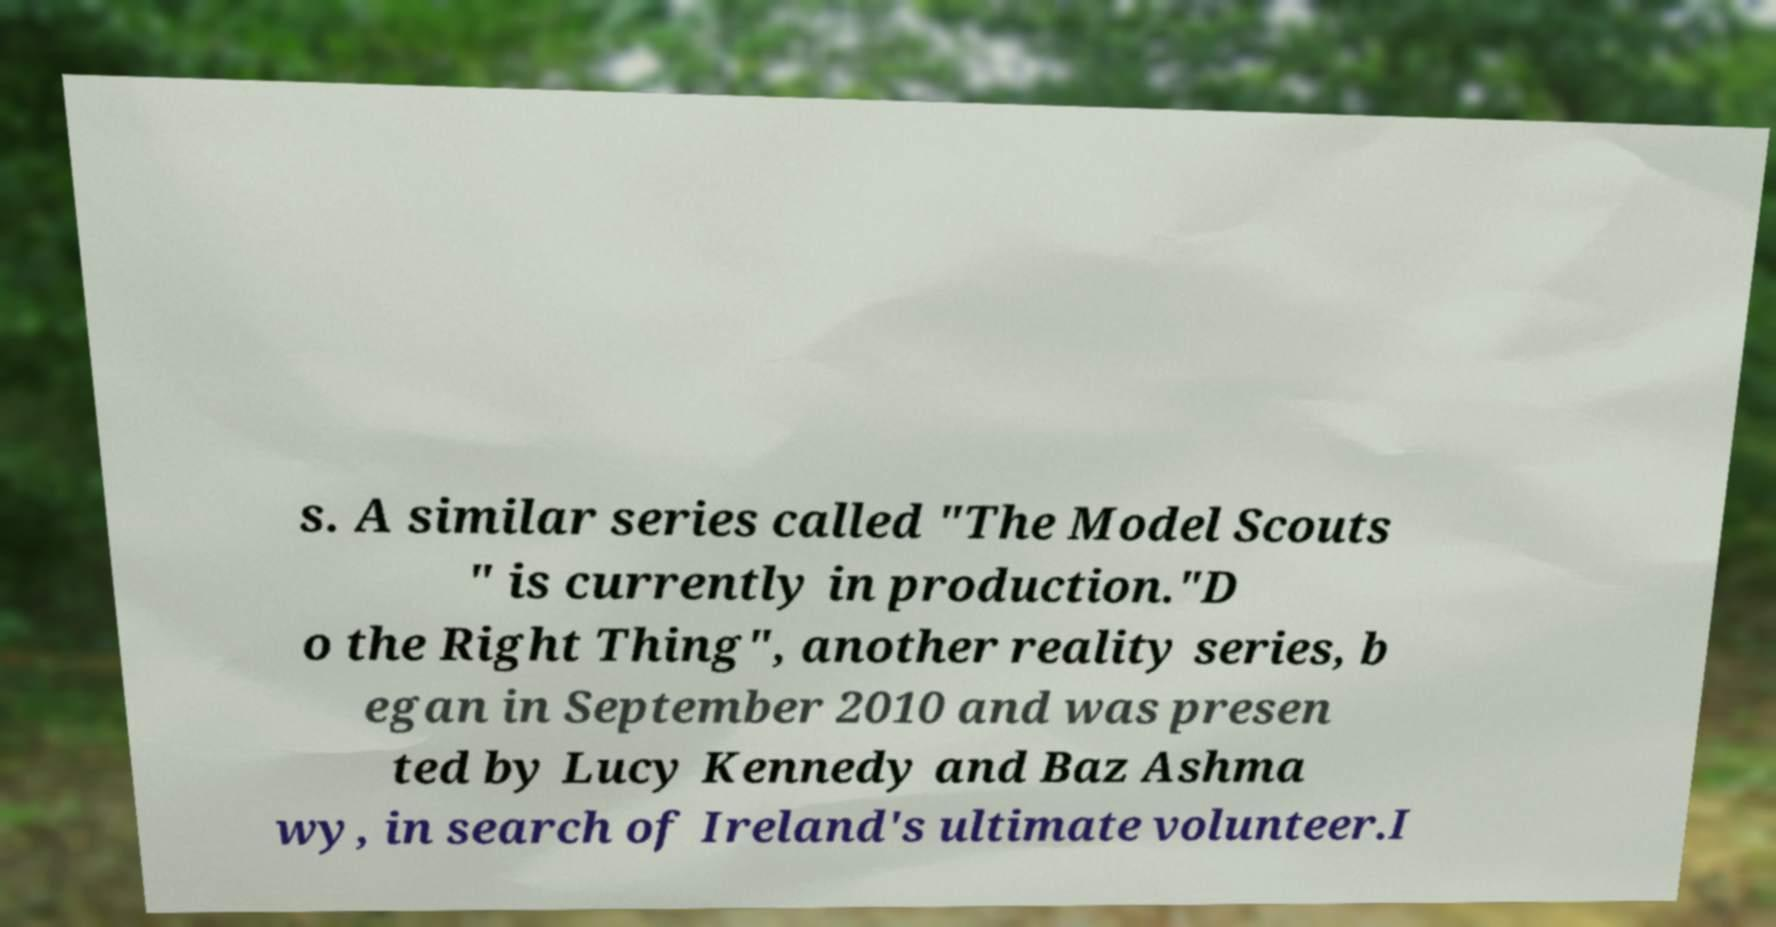Please read and relay the text visible in this image. What does it say? s. A similar series called "The Model Scouts " is currently in production."D o the Right Thing", another reality series, b egan in September 2010 and was presen ted by Lucy Kennedy and Baz Ashma wy, in search of Ireland's ultimate volunteer.I 